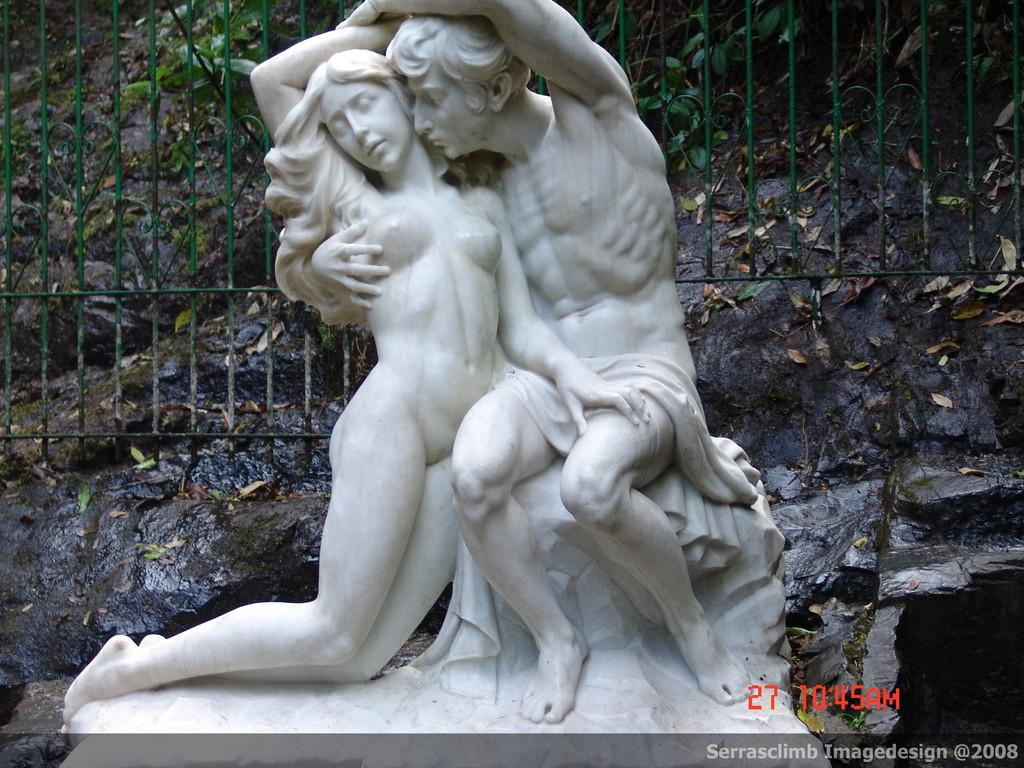What is the main subject in the image? There is a statue in the image. What can be seen in the background of the image? There is a grille, leaves, and a rock in the background of the image. Are there any visible marks or features in the image? Watermarks are visible in the right bottom of the image. What type of vest is the statue wearing in the image? The statue is not wearing a vest, as it is a statue and does not have clothing. 